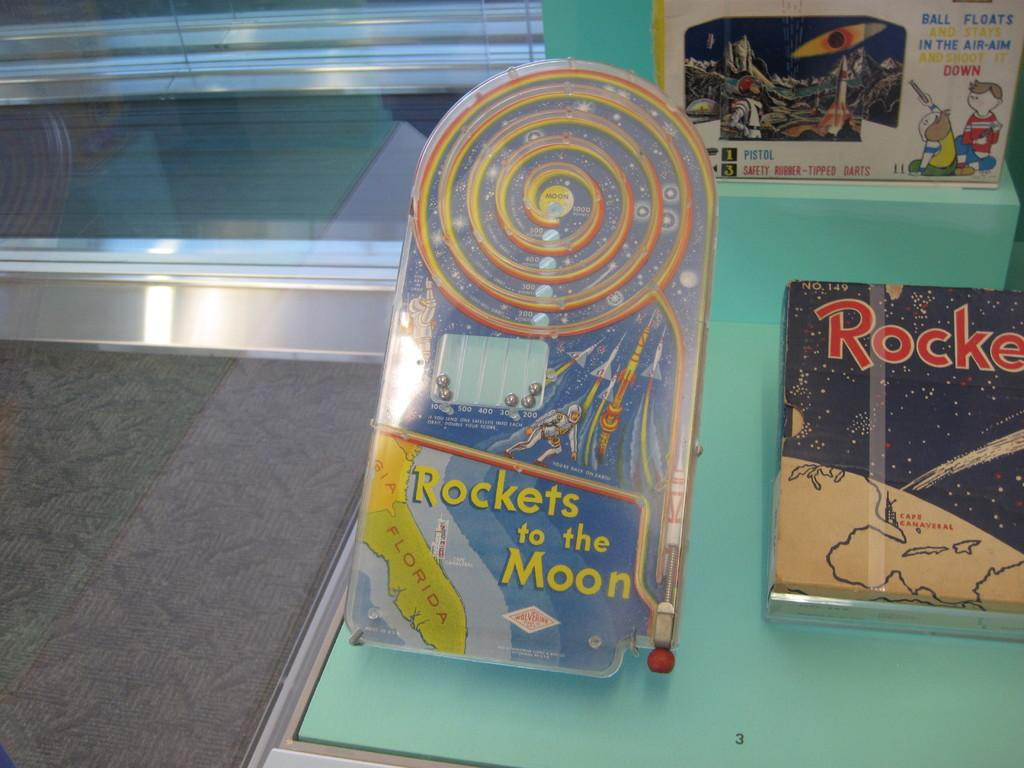<image>
Share a concise interpretation of the image provided. A game is shown called Rockets to the moon. 